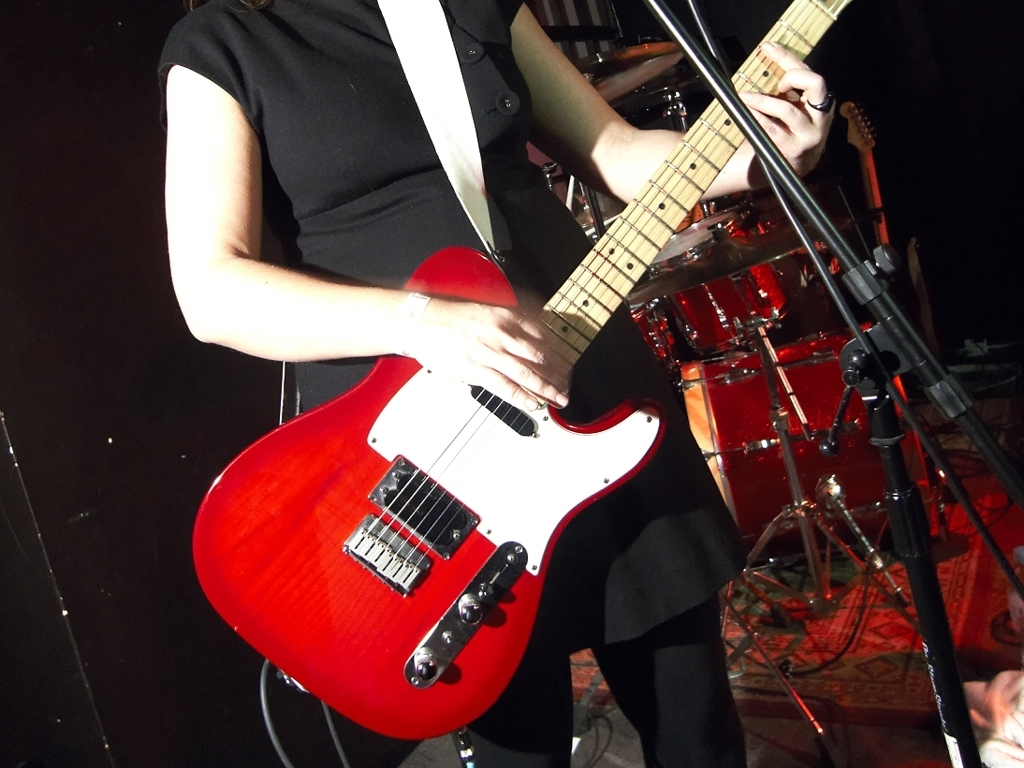What can we infer about the person in the image? We can infer that the person in the image is likely a musician, given the context of the music venue, and they are in the middle of a performance or rehearsal, as evidenced by the guitar strapped on and their positioning. 